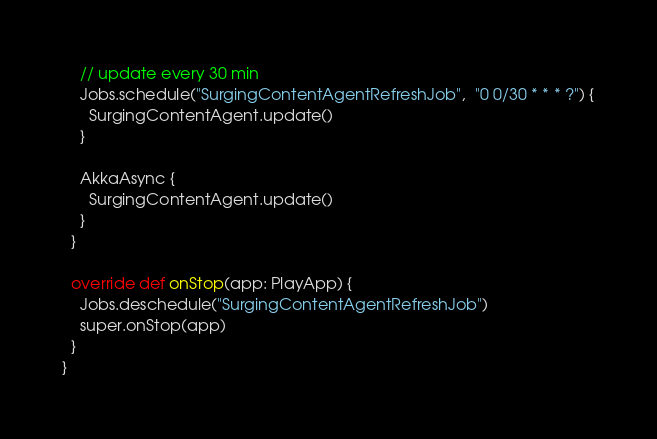Convert code to text. <code><loc_0><loc_0><loc_500><loc_500><_Scala_>
    // update every 30 min
    Jobs.schedule("SurgingContentAgentRefreshJob",  "0 0/30 * * * ?") {
      SurgingContentAgent.update()
    }

    AkkaAsync {
      SurgingContentAgent.update()
    }
  }

  override def onStop(app: PlayApp) {
    Jobs.deschedule("SurgingContentAgentRefreshJob")
    super.onStop(app)
  }
}
</code> 